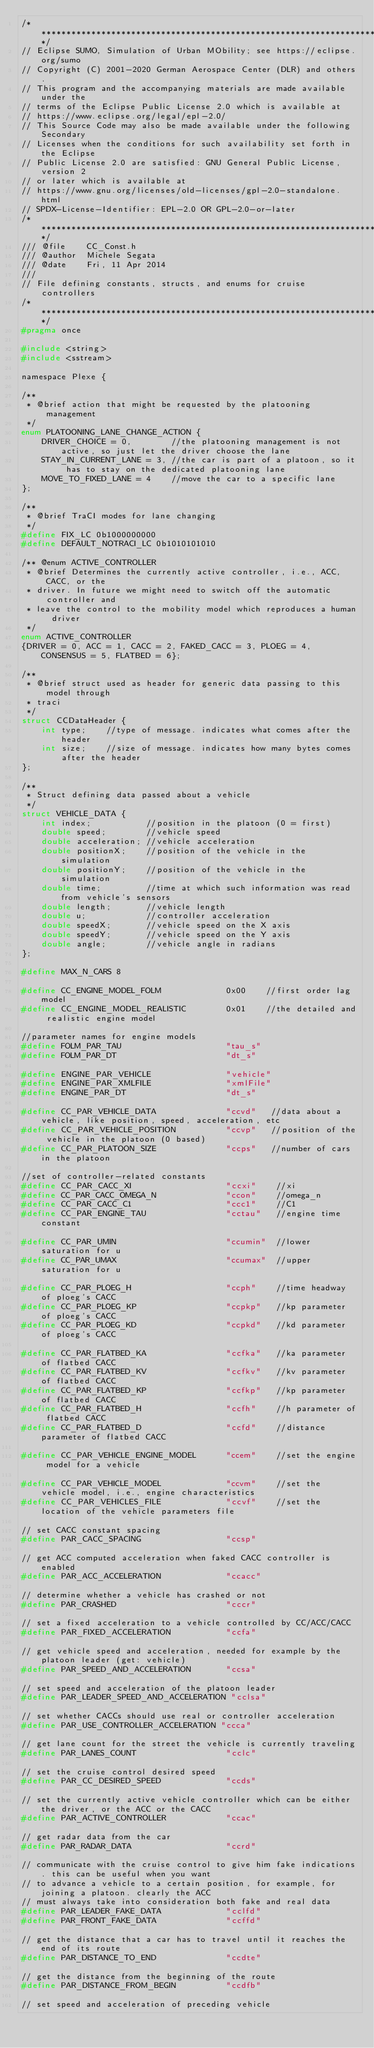<code> <loc_0><loc_0><loc_500><loc_500><_C_>/****************************************************************************/
// Eclipse SUMO, Simulation of Urban MObility; see https://eclipse.org/sumo
// Copyright (C) 2001-2020 German Aerospace Center (DLR) and others.
// This program and the accompanying materials are made available under the
// terms of the Eclipse Public License 2.0 which is available at
// https://www.eclipse.org/legal/epl-2.0/
// This Source Code may also be made available under the following Secondary
// Licenses when the conditions for such availability set forth in the Eclipse
// Public License 2.0 are satisfied: GNU General Public License, version 2
// or later which is available at
// https://www.gnu.org/licenses/old-licenses/gpl-2.0-standalone.html
// SPDX-License-Identifier: EPL-2.0 OR GPL-2.0-or-later
/****************************************************************************/
/// @file    CC_Const.h
/// @author  Michele Segata
/// @date    Fri, 11 Apr 2014
///
// File defining constants, structs, and enums for cruise controllers
/****************************************************************************/
#pragma once

#include <string>
#include <sstream>

namespace Plexe {

/**
 * @brief action that might be requested by the platooning management
 */
enum PLATOONING_LANE_CHANGE_ACTION {
    DRIVER_CHOICE = 0,        //the platooning management is not active, so just let the driver choose the lane
    STAY_IN_CURRENT_LANE = 3, //the car is part of a platoon, so it has to stay on the dedicated platooning lane
    MOVE_TO_FIXED_LANE = 4    //move the car to a specific lane
};

/**
 * @brief TraCI modes for lane changing
 */
#define FIX_LC 0b1000000000
#define DEFAULT_NOTRACI_LC 0b1010101010

/** @enum ACTIVE_CONTROLLER
 * @brief Determines the currently active controller, i.e., ACC, CACC, or the
 * driver. In future we might need to switch off the automatic controller and
 * leave the control to the mobility model which reproduces a human driver
 */
enum ACTIVE_CONTROLLER
{DRIVER = 0, ACC = 1, CACC = 2, FAKED_CACC = 3, PLOEG = 4, CONSENSUS = 5, FLATBED = 6};

/**
 * @brief struct used as header for generic data passing to this model through
 * traci
 */
struct CCDataHeader {
    int type;    //type of message. indicates what comes after the header
    int size;    //size of message. indicates how many bytes comes after the header
};

/**
 * Struct defining data passed about a vehicle
 */
struct VEHICLE_DATA {
    int index;           //position in the platoon (0 = first)
    double speed;        //vehicle speed
    double acceleration; //vehicle acceleration
    double positionX;    //position of the vehicle in the simulation
    double positionY;    //position of the vehicle in the simulation
    double time;         //time at which such information was read from vehicle's sensors
    double length;       //vehicle length
    double u;            //controller acceleration
    double speedX;       //vehicle speed on the X axis
    double speedY;       //vehicle speed on the Y axis
    double angle;        //vehicle angle in radians
};

#define MAX_N_CARS 8

#define CC_ENGINE_MODEL_FOLM             0x00    //first order lag model
#define CC_ENGINE_MODEL_REALISTIC        0x01    //the detailed and realistic engine model

//parameter names for engine models
#define FOLM_PAR_TAU                     "tau_s"
#define FOLM_PAR_DT                      "dt_s"

#define ENGINE_PAR_VEHICLE               "vehicle"
#define ENGINE_PAR_XMLFILE               "xmlFile"
#define ENGINE_PAR_DT                    "dt_s"

#define CC_PAR_VEHICLE_DATA              "ccvd"   //data about a vehicle, like position, speed, acceleration, etc
#define CC_PAR_VEHICLE_POSITION          "ccvp"   //position of the vehicle in the platoon (0 based)
#define CC_PAR_PLATOON_SIZE              "ccps"   //number of cars in the platoon

//set of controller-related constants
#define CC_PAR_CACC_XI                   "ccxi"    //xi
#define CC_PAR_CACC_OMEGA_N              "ccon"    //omega_n
#define CC_PAR_CACC_C1                   "ccc1"    //C1
#define CC_PAR_ENGINE_TAU                "cctau"   //engine time constant

#define CC_PAR_UMIN                      "ccumin"  //lower saturation for u
#define CC_PAR_UMAX                      "ccumax"  //upper saturation for u

#define CC_PAR_PLOEG_H                   "ccph"    //time headway of ploeg's CACC
#define CC_PAR_PLOEG_KP                  "ccpkp"   //kp parameter of ploeg's CACC
#define CC_PAR_PLOEG_KD                  "ccpkd"   //kd parameter of ploeg's CACC

#define CC_PAR_FLATBED_KA                "ccfka"   //ka parameter of flatbed CACC
#define CC_PAR_FLATBED_KV                "ccfkv"   //kv parameter of flatbed CACC
#define CC_PAR_FLATBED_KP                "ccfkp"   //kp parameter of flatbed CACC
#define CC_PAR_FLATBED_H                 "ccfh"    //h parameter of flatbed CACC
#define CC_PAR_FLATBED_D                 "ccfd"    //distance parameter of flatbed CACC

#define CC_PAR_VEHICLE_ENGINE_MODEL      "ccem"    //set the engine model for a vehicle

#define CC_PAR_VEHICLE_MODEL             "ccvm"    //set the vehicle model, i.e., engine characteristics
#define CC_PAR_VEHICLES_FILE             "ccvf"    //set the location of the vehicle parameters file

// set CACC constant spacing
#define PAR_CACC_SPACING                 "ccsp"

// get ACC computed acceleration when faked CACC controller is enabled
#define PAR_ACC_ACCELERATION             "ccacc"

// determine whether a vehicle has crashed or not
#define PAR_CRASHED                      "cccr"

// set a fixed acceleration to a vehicle controlled by CC/ACC/CACC
#define PAR_FIXED_ACCELERATION           "ccfa"

// get vehicle speed and acceleration, needed for example by the platoon leader (get: vehicle)
#define PAR_SPEED_AND_ACCELERATION       "ccsa"

// set speed and acceleration of the platoon leader
#define PAR_LEADER_SPEED_AND_ACCELERATION "cclsa"

// set whether CACCs should use real or controller acceleration
#define PAR_USE_CONTROLLER_ACCELERATION "ccca"

// get lane count for the street the vehicle is currently traveling
#define PAR_LANES_COUNT                  "cclc"

// set the cruise control desired speed
#define PAR_CC_DESIRED_SPEED             "ccds"

// set the currently active vehicle controller which can be either the driver, or the ACC or the CACC
#define PAR_ACTIVE_CONTROLLER            "ccac"

// get radar data from the car
#define PAR_RADAR_DATA                   "ccrd"

// communicate with the cruise control to give him fake indications. this can be useful when you want
// to advance a vehicle to a certain position, for example, for joining a platoon. clearly the ACC
// must always take into consideration both fake and real data
#define PAR_LEADER_FAKE_DATA             "cclfd"
#define PAR_FRONT_FAKE_DATA              "ccffd"

// get the distance that a car has to travel until it reaches the end of its route
#define PAR_DISTANCE_TO_END              "ccdte"

// get the distance from the beginning of the route
#define PAR_DISTANCE_FROM_BEGIN          "ccdfb"

// set speed and acceleration of preceding vehicle</code> 